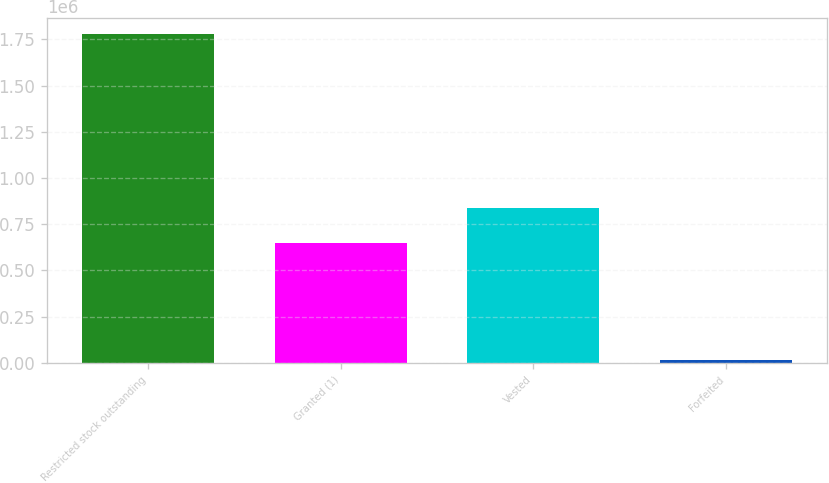Convert chart. <chart><loc_0><loc_0><loc_500><loc_500><bar_chart><fcel>Restricted stock outstanding<fcel>Granted (1)<fcel>Vested<fcel>Forfeited<nl><fcel>1.77743e+06<fcel>646142<fcel>837658<fcel>15573<nl></chart> 